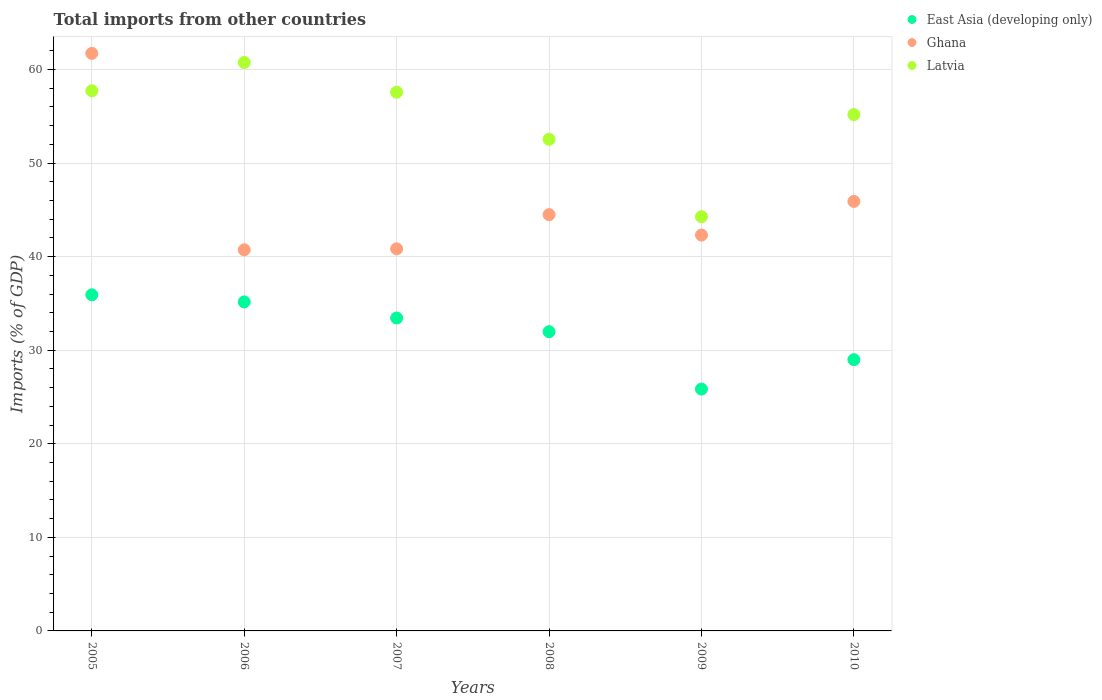How many different coloured dotlines are there?
Offer a terse response. 3. What is the total imports in Ghana in 2008?
Offer a terse response. 44.48. Across all years, what is the maximum total imports in East Asia (developing only)?
Provide a succinct answer. 35.92. Across all years, what is the minimum total imports in Latvia?
Your answer should be very brief. 44.27. What is the total total imports in East Asia (developing only) in the graph?
Give a very brief answer. 191.34. What is the difference between the total imports in Ghana in 2007 and that in 2009?
Offer a terse response. -1.47. What is the difference between the total imports in Latvia in 2005 and the total imports in Ghana in 2009?
Provide a succinct answer. 15.42. What is the average total imports in East Asia (developing only) per year?
Your answer should be very brief. 31.89. In the year 2005, what is the difference between the total imports in Ghana and total imports in Latvia?
Your response must be concise. 4. In how many years, is the total imports in Latvia greater than 60 %?
Provide a succinct answer. 1. What is the ratio of the total imports in Latvia in 2006 to that in 2008?
Make the answer very short. 1.16. What is the difference between the highest and the second highest total imports in Ghana?
Make the answer very short. 15.82. What is the difference between the highest and the lowest total imports in Latvia?
Offer a terse response. 16.48. Is the sum of the total imports in East Asia (developing only) in 2007 and 2010 greater than the maximum total imports in Latvia across all years?
Provide a succinct answer. Yes. Is the total imports in East Asia (developing only) strictly less than the total imports in Latvia over the years?
Ensure brevity in your answer.  Yes. Are the values on the major ticks of Y-axis written in scientific E-notation?
Provide a succinct answer. No. Does the graph contain any zero values?
Your answer should be very brief. No. Does the graph contain grids?
Ensure brevity in your answer.  Yes. How are the legend labels stacked?
Offer a very short reply. Vertical. What is the title of the graph?
Offer a terse response. Total imports from other countries. Does "Bahamas" appear as one of the legend labels in the graph?
Offer a very short reply. No. What is the label or title of the X-axis?
Your response must be concise. Years. What is the label or title of the Y-axis?
Ensure brevity in your answer.  Imports (% of GDP). What is the Imports (% of GDP) of East Asia (developing only) in 2005?
Provide a short and direct response. 35.92. What is the Imports (% of GDP) in Ghana in 2005?
Provide a succinct answer. 61.72. What is the Imports (% of GDP) of Latvia in 2005?
Your answer should be compact. 57.72. What is the Imports (% of GDP) in East Asia (developing only) in 2006?
Offer a very short reply. 35.16. What is the Imports (% of GDP) of Ghana in 2006?
Give a very brief answer. 40.73. What is the Imports (% of GDP) in Latvia in 2006?
Your response must be concise. 60.75. What is the Imports (% of GDP) in East Asia (developing only) in 2007?
Keep it short and to the point. 33.44. What is the Imports (% of GDP) in Ghana in 2007?
Offer a terse response. 40.83. What is the Imports (% of GDP) of Latvia in 2007?
Your answer should be very brief. 57.57. What is the Imports (% of GDP) in East Asia (developing only) in 2008?
Keep it short and to the point. 31.98. What is the Imports (% of GDP) in Ghana in 2008?
Your response must be concise. 44.48. What is the Imports (% of GDP) in Latvia in 2008?
Your response must be concise. 52.54. What is the Imports (% of GDP) of East Asia (developing only) in 2009?
Your answer should be very brief. 25.85. What is the Imports (% of GDP) of Ghana in 2009?
Offer a terse response. 42.3. What is the Imports (% of GDP) in Latvia in 2009?
Offer a very short reply. 44.27. What is the Imports (% of GDP) in East Asia (developing only) in 2010?
Your answer should be compact. 28.99. What is the Imports (% of GDP) of Ghana in 2010?
Give a very brief answer. 45.9. What is the Imports (% of GDP) of Latvia in 2010?
Offer a very short reply. 55.18. Across all years, what is the maximum Imports (% of GDP) of East Asia (developing only)?
Keep it short and to the point. 35.92. Across all years, what is the maximum Imports (% of GDP) of Ghana?
Your response must be concise. 61.72. Across all years, what is the maximum Imports (% of GDP) in Latvia?
Provide a short and direct response. 60.75. Across all years, what is the minimum Imports (% of GDP) in East Asia (developing only)?
Keep it short and to the point. 25.85. Across all years, what is the minimum Imports (% of GDP) in Ghana?
Offer a very short reply. 40.73. Across all years, what is the minimum Imports (% of GDP) in Latvia?
Your answer should be compact. 44.27. What is the total Imports (% of GDP) in East Asia (developing only) in the graph?
Your answer should be compact. 191.34. What is the total Imports (% of GDP) of Ghana in the graph?
Your response must be concise. 275.97. What is the total Imports (% of GDP) in Latvia in the graph?
Your answer should be compact. 328.03. What is the difference between the Imports (% of GDP) of East Asia (developing only) in 2005 and that in 2006?
Offer a terse response. 0.76. What is the difference between the Imports (% of GDP) in Ghana in 2005 and that in 2006?
Provide a short and direct response. 20.99. What is the difference between the Imports (% of GDP) in Latvia in 2005 and that in 2006?
Provide a short and direct response. -3.02. What is the difference between the Imports (% of GDP) of East Asia (developing only) in 2005 and that in 2007?
Offer a very short reply. 2.48. What is the difference between the Imports (% of GDP) of Ghana in 2005 and that in 2007?
Provide a short and direct response. 20.89. What is the difference between the Imports (% of GDP) in Latvia in 2005 and that in 2007?
Make the answer very short. 0.15. What is the difference between the Imports (% of GDP) in East Asia (developing only) in 2005 and that in 2008?
Make the answer very short. 3.94. What is the difference between the Imports (% of GDP) in Ghana in 2005 and that in 2008?
Provide a short and direct response. 17.24. What is the difference between the Imports (% of GDP) in Latvia in 2005 and that in 2008?
Make the answer very short. 5.18. What is the difference between the Imports (% of GDP) of East Asia (developing only) in 2005 and that in 2009?
Ensure brevity in your answer.  10.07. What is the difference between the Imports (% of GDP) in Ghana in 2005 and that in 2009?
Offer a terse response. 19.42. What is the difference between the Imports (% of GDP) in Latvia in 2005 and that in 2009?
Give a very brief answer. 13.46. What is the difference between the Imports (% of GDP) in East Asia (developing only) in 2005 and that in 2010?
Give a very brief answer. 6.93. What is the difference between the Imports (% of GDP) of Ghana in 2005 and that in 2010?
Offer a very short reply. 15.82. What is the difference between the Imports (% of GDP) of Latvia in 2005 and that in 2010?
Provide a succinct answer. 2.54. What is the difference between the Imports (% of GDP) in East Asia (developing only) in 2006 and that in 2007?
Ensure brevity in your answer.  1.72. What is the difference between the Imports (% of GDP) in Ghana in 2006 and that in 2007?
Your answer should be compact. -0.1. What is the difference between the Imports (% of GDP) in Latvia in 2006 and that in 2007?
Provide a short and direct response. 3.17. What is the difference between the Imports (% of GDP) in East Asia (developing only) in 2006 and that in 2008?
Provide a short and direct response. 3.18. What is the difference between the Imports (% of GDP) in Ghana in 2006 and that in 2008?
Your response must be concise. -3.75. What is the difference between the Imports (% of GDP) of Latvia in 2006 and that in 2008?
Provide a short and direct response. 8.21. What is the difference between the Imports (% of GDP) in East Asia (developing only) in 2006 and that in 2009?
Keep it short and to the point. 9.32. What is the difference between the Imports (% of GDP) of Ghana in 2006 and that in 2009?
Provide a succinct answer. -1.57. What is the difference between the Imports (% of GDP) in Latvia in 2006 and that in 2009?
Give a very brief answer. 16.48. What is the difference between the Imports (% of GDP) of East Asia (developing only) in 2006 and that in 2010?
Provide a succinct answer. 6.18. What is the difference between the Imports (% of GDP) of Ghana in 2006 and that in 2010?
Your answer should be very brief. -5.17. What is the difference between the Imports (% of GDP) of Latvia in 2006 and that in 2010?
Provide a succinct answer. 5.57. What is the difference between the Imports (% of GDP) in East Asia (developing only) in 2007 and that in 2008?
Offer a terse response. 1.46. What is the difference between the Imports (% of GDP) of Ghana in 2007 and that in 2008?
Your answer should be very brief. -3.66. What is the difference between the Imports (% of GDP) in Latvia in 2007 and that in 2008?
Make the answer very short. 5.03. What is the difference between the Imports (% of GDP) in East Asia (developing only) in 2007 and that in 2009?
Your answer should be very brief. 7.59. What is the difference between the Imports (% of GDP) in Ghana in 2007 and that in 2009?
Offer a terse response. -1.47. What is the difference between the Imports (% of GDP) in Latvia in 2007 and that in 2009?
Give a very brief answer. 13.31. What is the difference between the Imports (% of GDP) of East Asia (developing only) in 2007 and that in 2010?
Offer a terse response. 4.45. What is the difference between the Imports (% of GDP) in Ghana in 2007 and that in 2010?
Make the answer very short. -5.07. What is the difference between the Imports (% of GDP) in Latvia in 2007 and that in 2010?
Your answer should be compact. 2.39. What is the difference between the Imports (% of GDP) in East Asia (developing only) in 2008 and that in 2009?
Provide a short and direct response. 6.13. What is the difference between the Imports (% of GDP) in Ghana in 2008 and that in 2009?
Your answer should be very brief. 2.18. What is the difference between the Imports (% of GDP) of Latvia in 2008 and that in 2009?
Ensure brevity in your answer.  8.27. What is the difference between the Imports (% of GDP) of East Asia (developing only) in 2008 and that in 2010?
Your answer should be compact. 2.99. What is the difference between the Imports (% of GDP) in Ghana in 2008 and that in 2010?
Your answer should be very brief. -1.42. What is the difference between the Imports (% of GDP) of Latvia in 2008 and that in 2010?
Make the answer very short. -2.64. What is the difference between the Imports (% of GDP) of East Asia (developing only) in 2009 and that in 2010?
Provide a short and direct response. -3.14. What is the difference between the Imports (% of GDP) in Ghana in 2009 and that in 2010?
Offer a terse response. -3.6. What is the difference between the Imports (% of GDP) of Latvia in 2009 and that in 2010?
Your answer should be compact. -10.92. What is the difference between the Imports (% of GDP) of East Asia (developing only) in 2005 and the Imports (% of GDP) of Ghana in 2006?
Make the answer very short. -4.81. What is the difference between the Imports (% of GDP) of East Asia (developing only) in 2005 and the Imports (% of GDP) of Latvia in 2006?
Keep it short and to the point. -24.83. What is the difference between the Imports (% of GDP) in Ghana in 2005 and the Imports (% of GDP) in Latvia in 2006?
Your answer should be very brief. 0.97. What is the difference between the Imports (% of GDP) in East Asia (developing only) in 2005 and the Imports (% of GDP) in Ghana in 2007?
Provide a succinct answer. -4.91. What is the difference between the Imports (% of GDP) of East Asia (developing only) in 2005 and the Imports (% of GDP) of Latvia in 2007?
Make the answer very short. -21.65. What is the difference between the Imports (% of GDP) in Ghana in 2005 and the Imports (% of GDP) in Latvia in 2007?
Offer a very short reply. 4.15. What is the difference between the Imports (% of GDP) of East Asia (developing only) in 2005 and the Imports (% of GDP) of Ghana in 2008?
Make the answer very short. -8.57. What is the difference between the Imports (% of GDP) in East Asia (developing only) in 2005 and the Imports (% of GDP) in Latvia in 2008?
Your answer should be compact. -16.62. What is the difference between the Imports (% of GDP) of Ghana in 2005 and the Imports (% of GDP) of Latvia in 2008?
Offer a terse response. 9.18. What is the difference between the Imports (% of GDP) in East Asia (developing only) in 2005 and the Imports (% of GDP) in Ghana in 2009?
Your answer should be compact. -6.38. What is the difference between the Imports (% of GDP) in East Asia (developing only) in 2005 and the Imports (% of GDP) in Latvia in 2009?
Your answer should be compact. -8.35. What is the difference between the Imports (% of GDP) of Ghana in 2005 and the Imports (% of GDP) of Latvia in 2009?
Provide a succinct answer. 17.46. What is the difference between the Imports (% of GDP) of East Asia (developing only) in 2005 and the Imports (% of GDP) of Ghana in 2010?
Your answer should be compact. -9.98. What is the difference between the Imports (% of GDP) in East Asia (developing only) in 2005 and the Imports (% of GDP) in Latvia in 2010?
Provide a succinct answer. -19.26. What is the difference between the Imports (% of GDP) of Ghana in 2005 and the Imports (% of GDP) of Latvia in 2010?
Your answer should be compact. 6.54. What is the difference between the Imports (% of GDP) in East Asia (developing only) in 2006 and the Imports (% of GDP) in Ghana in 2007?
Your answer should be compact. -5.67. What is the difference between the Imports (% of GDP) in East Asia (developing only) in 2006 and the Imports (% of GDP) in Latvia in 2007?
Offer a very short reply. -22.41. What is the difference between the Imports (% of GDP) in Ghana in 2006 and the Imports (% of GDP) in Latvia in 2007?
Ensure brevity in your answer.  -16.84. What is the difference between the Imports (% of GDP) in East Asia (developing only) in 2006 and the Imports (% of GDP) in Ghana in 2008?
Make the answer very short. -9.32. What is the difference between the Imports (% of GDP) in East Asia (developing only) in 2006 and the Imports (% of GDP) in Latvia in 2008?
Provide a short and direct response. -17.38. What is the difference between the Imports (% of GDP) in Ghana in 2006 and the Imports (% of GDP) in Latvia in 2008?
Offer a very short reply. -11.81. What is the difference between the Imports (% of GDP) of East Asia (developing only) in 2006 and the Imports (% of GDP) of Ghana in 2009?
Provide a short and direct response. -7.14. What is the difference between the Imports (% of GDP) of East Asia (developing only) in 2006 and the Imports (% of GDP) of Latvia in 2009?
Keep it short and to the point. -9.1. What is the difference between the Imports (% of GDP) in Ghana in 2006 and the Imports (% of GDP) in Latvia in 2009?
Provide a succinct answer. -3.54. What is the difference between the Imports (% of GDP) of East Asia (developing only) in 2006 and the Imports (% of GDP) of Ghana in 2010?
Your response must be concise. -10.74. What is the difference between the Imports (% of GDP) in East Asia (developing only) in 2006 and the Imports (% of GDP) in Latvia in 2010?
Keep it short and to the point. -20.02. What is the difference between the Imports (% of GDP) in Ghana in 2006 and the Imports (% of GDP) in Latvia in 2010?
Your answer should be compact. -14.45. What is the difference between the Imports (% of GDP) of East Asia (developing only) in 2007 and the Imports (% of GDP) of Ghana in 2008?
Your answer should be very brief. -11.04. What is the difference between the Imports (% of GDP) of East Asia (developing only) in 2007 and the Imports (% of GDP) of Latvia in 2008?
Provide a short and direct response. -19.1. What is the difference between the Imports (% of GDP) in Ghana in 2007 and the Imports (% of GDP) in Latvia in 2008?
Offer a very short reply. -11.71. What is the difference between the Imports (% of GDP) of East Asia (developing only) in 2007 and the Imports (% of GDP) of Ghana in 2009?
Your answer should be compact. -8.86. What is the difference between the Imports (% of GDP) of East Asia (developing only) in 2007 and the Imports (% of GDP) of Latvia in 2009?
Ensure brevity in your answer.  -10.82. What is the difference between the Imports (% of GDP) in Ghana in 2007 and the Imports (% of GDP) in Latvia in 2009?
Provide a short and direct response. -3.44. What is the difference between the Imports (% of GDP) in East Asia (developing only) in 2007 and the Imports (% of GDP) in Ghana in 2010?
Your answer should be compact. -12.46. What is the difference between the Imports (% of GDP) in East Asia (developing only) in 2007 and the Imports (% of GDP) in Latvia in 2010?
Offer a very short reply. -21.74. What is the difference between the Imports (% of GDP) in Ghana in 2007 and the Imports (% of GDP) in Latvia in 2010?
Your answer should be compact. -14.35. What is the difference between the Imports (% of GDP) of East Asia (developing only) in 2008 and the Imports (% of GDP) of Ghana in 2009?
Keep it short and to the point. -10.32. What is the difference between the Imports (% of GDP) in East Asia (developing only) in 2008 and the Imports (% of GDP) in Latvia in 2009?
Ensure brevity in your answer.  -12.29. What is the difference between the Imports (% of GDP) of Ghana in 2008 and the Imports (% of GDP) of Latvia in 2009?
Your answer should be compact. 0.22. What is the difference between the Imports (% of GDP) of East Asia (developing only) in 2008 and the Imports (% of GDP) of Ghana in 2010?
Make the answer very short. -13.92. What is the difference between the Imports (% of GDP) of East Asia (developing only) in 2008 and the Imports (% of GDP) of Latvia in 2010?
Keep it short and to the point. -23.2. What is the difference between the Imports (% of GDP) of Ghana in 2008 and the Imports (% of GDP) of Latvia in 2010?
Your response must be concise. -10.7. What is the difference between the Imports (% of GDP) in East Asia (developing only) in 2009 and the Imports (% of GDP) in Ghana in 2010?
Give a very brief answer. -20.05. What is the difference between the Imports (% of GDP) in East Asia (developing only) in 2009 and the Imports (% of GDP) in Latvia in 2010?
Provide a short and direct response. -29.33. What is the difference between the Imports (% of GDP) of Ghana in 2009 and the Imports (% of GDP) of Latvia in 2010?
Offer a very short reply. -12.88. What is the average Imports (% of GDP) in East Asia (developing only) per year?
Make the answer very short. 31.89. What is the average Imports (% of GDP) in Ghana per year?
Provide a short and direct response. 46. What is the average Imports (% of GDP) in Latvia per year?
Make the answer very short. 54.67. In the year 2005, what is the difference between the Imports (% of GDP) in East Asia (developing only) and Imports (% of GDP) in Ghana?
Keep it short and to the point. -25.8. In the year 2005, what is the difference between the Imports (% of GDP) of East Asia (developing only) and Imports (% of GDP) of Latvia?
Ensure brevity in your answer.  -21.81. In the year 2005, what is the difference between the Imports (% of GDP) in Ghana and Imports (% of GDP) in Latvia?
Keep it short and to the point. 4. In the year 2006, what is the difference between the Imports (% of GDP) of East Asia (developing only) and Imports (% of GDP) of Ghana?
Make the answer very short. -5.57. In the year 2006, what is the difference between the Imports (% of GDP) in East Asia (developing only) and Imports (% of GDP) in Latvia?
Ensure brevity in your answer.  -25.58. In the year 2006, what is the difference between the Imports (% of GDP) of Ghana and Imports (% of GDP) of Latvia?
Offer a very short reply. -20.02. In the year 2007, what is the difference between the Imports (% of GDP) of East Asia (developing only) and Imports (% of GDP) of Ghana?
Make the answer very short. -7.39. In the year 2007, what is the difference between the Imports (% of GDP) of East Asia (developing only) and Imports (% of GDP) of Latvia?
Make the answer very short. -24.13. In the year 2007, what is the difference between the Imports (% of GDP) of Ghana and Imports (% of GDP) of Latvia?
Make the answer very short. -16.74. In the year 2008, what is the difference between the Imports (% of GDP) in East Asia (developing only) and Imports (% of GDP) in Ghana?
Provide a succinct answer. -12.51. In the year 2008, what is the difference between the Imports (% of GDP) in East Asia (developing only) and Imports (% of GDP) in Latvia?
Ensure brevity in your answer.  -20.56. In the year 2008, what is the difference between the Imports (% of GDP) in Ghana and Imports (% of GDP) in Latvia?
Provide a succinct answer. -8.05. In the year 2009, what is the difference between the Imports (% of GDP) of East Asia (developing only) and Imports (% of GDP) of Ghana?
Your answer should be compact. -16.46. In the year 2009, what is the difference between the Imports (% of GDP) of East Asia (developing only) and Imports (% of GDP) of Latvia?
Offer a very short reply. -18.42. In the year 2009, what is the difference between the Imports (% of GDP) in Ghana and Imports (% of GDP) in Latvia?
Keep it short and to the point. -1.96. In the year 2010, what is the difference between the Imports (% of GDP) in East Asia (developing only) and Imports (% of GDP) in Ghana?
Offer a very short reply. -16.91. In the year 2010, what is the difference between the Imports (% of GDP) of East Asia (developing only) and Imports (% of GDP) of Latvia?
Keep it short and to the point. -26.19. In the year 2010, what is the difference between the Imports (% of GDP) of Ghana and Imports (% of GDP) of Latvia?
Your response must be concise. -9.28. What is the ratio of the Imports (% of GDP) in East Asia (developing only) in 2005 to that in 2006?
Offer a terse response. 1.02. What is the ratio of the Imports (% of GDP) in Ghana in 2005 to that in 2006?
Your response must be concise. 1.52. What is the ratio of the Imports (% of GDP) of Latvia in 2005 to that in 2006?
Offer a terse response. 0.95. What is the ratio of the Imports (% of GDP) of East Asia (developing only) in 2005 to that in 2007?
Ensure brevity in your answer.  1.07. What is the ratio of the Imports (% of GDP) in Ghana in 2005 to that in 2007?
Provide a short and direct response. 1.51. What is the ratio of the Imports (% of GDP) in Latvia in 2005 to that in 2007?
Your response must be concise. 1. What is the ratio of the Imports (% of GDP) of East Asia (developing only) in 2005 to that in 2008?
Keep it short and to the point. 1.12. What is the ratio of the Imports (% of GDP) of Ghana in 2005 to that in 2008?
Provide a succinct answer. 1.39. What is the ratio of the Imports (% of GDP) of Latvia in 2005 to that in 2008?
Your answer should be compact. 1.1. What is the ratio of the Imports (% of GDP) in East Asia (developing only) in 2005 to that in 2009?
Make the answer very short. 1.39. What is the ratio of the Imports (% of GDP) of Ghana in 2005 to that in 2009?
Your response must be concise. 1.46. What is the ratio of the Imports (% of GDP) of Latvia in 2005 to that in 2009?
Keep it short and to the point. 1.3. What is the ratio of the Imports (% of GDP) of East Asia (developing only) in 2005 to that in 2010?
Offer a terse response. 1.24. What is the ratio of the Imports (% of GDP) of Ghana in 2005 to that in 2010?
Your answer should be compact. 1.34. What is the ratio of the Imports (% of GDP) of Latvia in 2005 to that in 2010?
Provide a succinct answer. 1.05. What is the ratio of the Imports (% of GDP) in East Asia (developing only) in 2006 to that in 2007?
Keep it short and to the point. 1.05. What is the ratio of the Imports (% of GDP) of Latvia in 2006 to that in 2007?
Give a very brief answer. 1.06. What is the ratio of the Imports (% of GDP) of East Asia (developing only) in 2006 to that in 2008?
Give a very brief answer. 1.1. What is the ratio of the Imports (% of GDP) in Ghana in 2006 to that in 2008?
Your answer should be very brief. 0.92. What is the ratio of the Imports (% of GDP) in Latvia in 2006 to that in 2008?
Offer a very short reply. 1.16. What is the ratio of the Imports (% of GDP) of East Asia (developing only) in 2006 to that in 2009?
Give a very brief answer. 1.36. What is the ratio of the Imports (% of GDP) of Ghana in 2006 to that in 2009?
Give a very brief answer. 0.96. What is the ratio of the Imports (% of GDP) of Latvia in 2006 to that in 2009?
Keep it short and to the point. 1.37. What is the ratio of the Imports (% of GDP) in East Asia (developing only) in 2006 to that in 2010?
Offer a terse response. 1.21. What is the ratio of the Imports (% of GDP) of Ghana in 2006 to that in 2010?
Offer a terse response. 0.89. What is the ratio of the Imports (% of GDP) in Latvia in 2006 to that in 2010?
Your answer should be compact. 1.1. What is the ratio of the Imports (% of GDP) in East Asia (developing only) in 2007 to that in 2008?
Offer a very short reply. 1.05. What is the ratio of the Imports (% of GDP) in Ghana in 2007 to that in 2008?
Ensure brevity in your answer.  0.92. What is the ratio of the Imports (% of GDP) of Latvia in 2007 to that in 2008?
Offer a very short reply. 1.1. What is the ratio of the Imports (% of GDP) in East Asia (developing only) in 2007 to that in 2009?
Make the answer very short. 1.29. What is the ratio of the Imports (% of GDP) in Ghana in 2007 to that in 2009?
Your answer should be compact. 0.97. What is the ratio of the Imports (% of GDP) of Latvia in 2007 to that in 2009?
Make the answer very short. 1.3. What is the ratio of the Imports (% of GDP) in East Asia (developing only) in 2007 to that in 2010?
Provide a short and direct response. 1.15. What is the ratio of the Imports (% of GDP) of Ghana in 2007 to that in 2010?
Make the answer very short. 0.89. What is the ratio of the Imports (% of GDP) of Latvia in 2007 to that in 2010?
Your answer should be compact. 1.04. What is the ratio of the Imports (% of GDP) in East Asia (developing only) in 2008 to that in 2009?
Ensure brevity in your answer.  1.24. What is the ratio of the Imports (% of GDP) of Ghana in 2008 to that in 2009?
Give a very brief answer. 1.05. What is the ratio of the Imports (% of GDP) of Latvia in 2008 to that in 2009?
Ensure brevity in your answer.  1.19. What is the ratio of the Imports (% of GDP) in East Asia (developing only) in 2008 to that in 2010?
Your response must be concise. 1.1. What is the ratio of the Imports (% of GDP) of Ghana in 2008 to that in 2010?
Ensure brevity in your answer.  0.97. What is the ratio of the Imports (% of GDP) of Latvia in 2008 to that in 2010?
Make the answer very short. 0.95. What is the ratio of the Imports (% of GDP) in East Asia (developing only) in 2009 to that in 2010?
Make the answer very short. 0.89. What is the ratio of the Imports (% of GDP) of Ghana in 2009 to that in 2010?
Make the answer very short. 0.92. What is the ratio of the Imports (% of GDP) in Latvia in 2009 to that in 2010?
Your response must be concise. 0.8. What is the difference between the highest and the second highest Imports (% of GDP) in East Asia (developing only)?
Provide a short and direct response. 0.76. What is the difference between the highest and the second highest Imports (% of GDP) in Ghana?
Keep it short and to the point. 15.82. What is the difference between the highest and the second highest Imports (% of GDP) of Latvia?
Provide a short and direct response. 3.02. What is the difference between the highest and the lowest Imports (% of GDP) in East Asia (developing only)?
Your answer should be very brief. 10.07. What is the difference between the highest and the lowest Imports (% of GDP) in Ghana?
Keep it short and to the point. 20.99. What is the difference between the highest and the lowest Imports (% of GDP) in Latvia?
Keep it short and to the point. 16.48. 